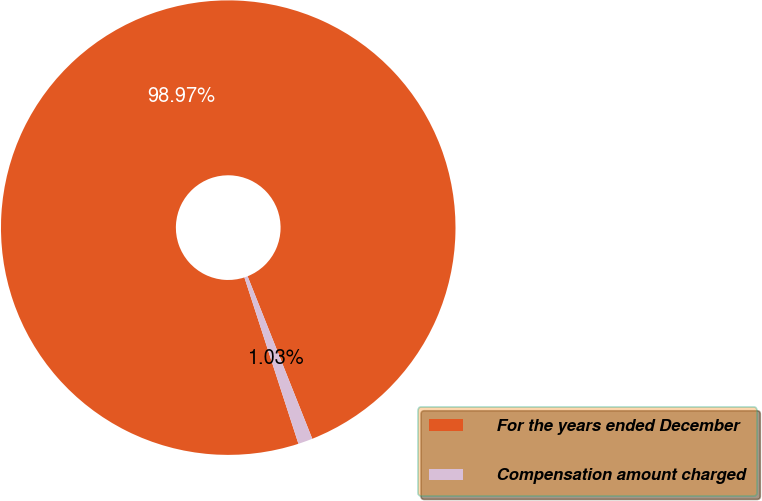Convert chart. <chart><loc_0><loc_0><loc_500><loc_500><pie_chart><fcel>For the years ended December<fcel>Compensation amount charged<nl><fcel>98.97%<fcel>1.03%<nl></chart> 